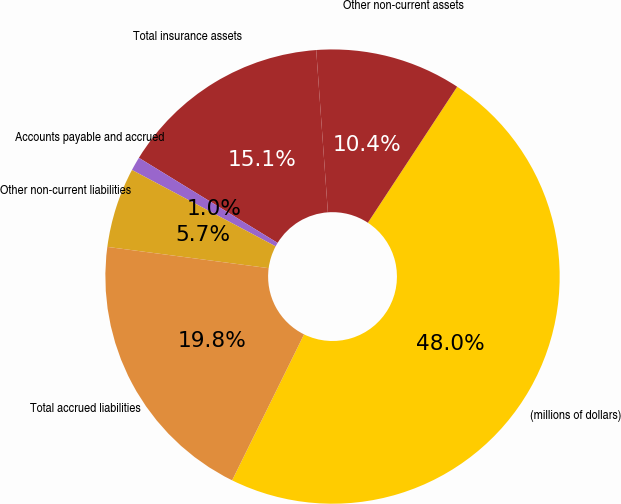<chart> <loc_0><loc_0><loc_500><loc_500><pie_chart><fcel>(millions of dollars)<fcel>Other non-current assets<fcel>Total insurance assets<fcel>Accounts payable and accrued<fcel>Other non-current liabilities<fcel>Total accrued liabilities<nl><fcel>48.04%<fcel>10.39%<fcel>15.1%<fcel>0.98%<fcel>5.69%<fcel>19.8%<nl></chart> 